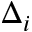Convert formula to latex. <formula><loc_0><loc_0><loc_500><loc_500>\Delta _ { i }</formula> 